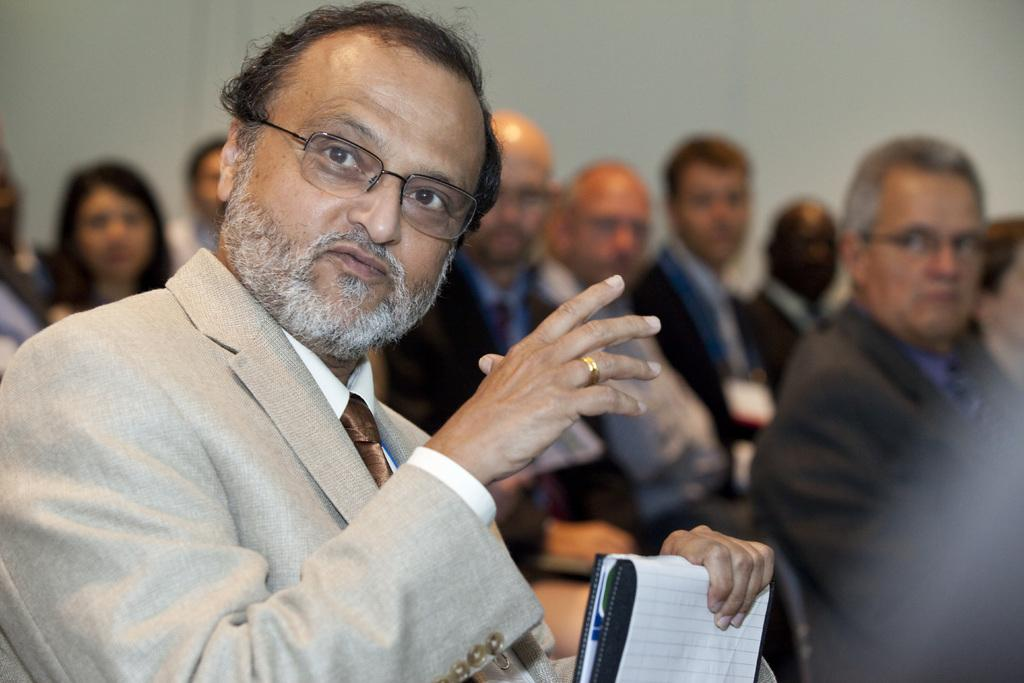What is the main subject of the image? The main subject of the image is a group of people. Can you describe the man on the left side of the image? The man on the left side of the image is wearing spectacles. What is the man holding in the image? The man is holding a book. Can you tell me how many horses are present in the image? There are no horses present in the image. What type of jelly is being used to rub on the man's spectacles in the image? There is no jelly or rubbing action involving the man's spectacles in the image. 